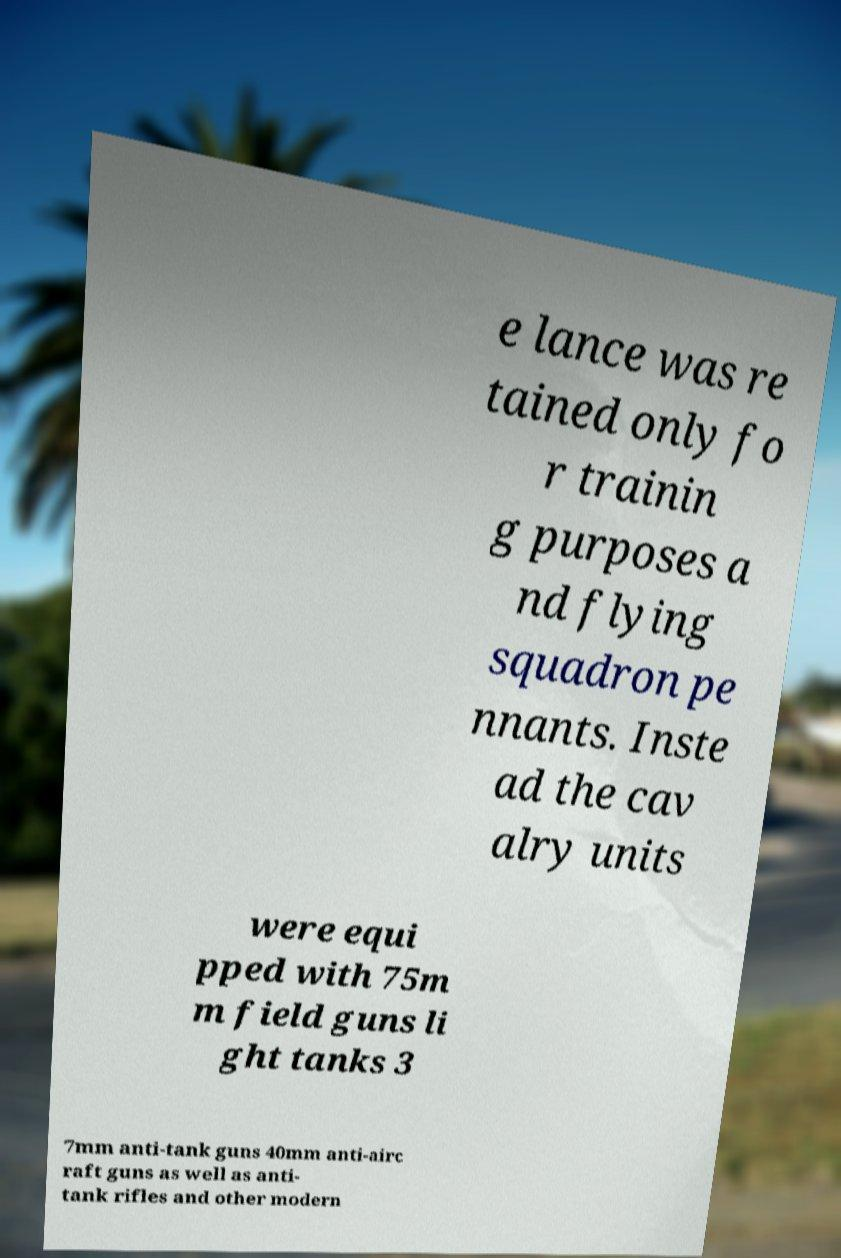Please identify and transcribe the text found in this image. e lance was re tained only fo r trainin g purposes a nd flying squadron pe nnants. Inste ad the cav alry units were equi pped with 75m m field guns li ght tanks 3 7mm anti-tank guns 40mm anti-airc raft guns as well as anti- tank rifles and other modern 